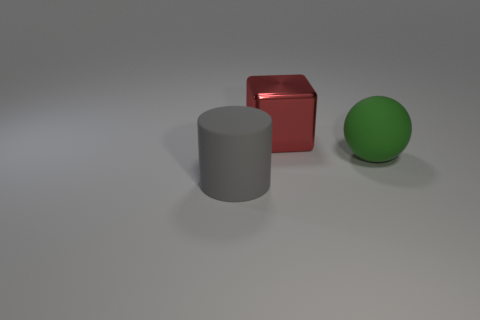What material is the big object behind the big green matte ball?
Ensure brevity in your answer.  Metal. What material is the thing that is behind the rubber thing to the right of the red metallic block?
Your answer should be compact. Metal. Is the number of big things that are on the right side of the metal block greater than the number of tiny gray cylinders?
Provide a succinct answer. Yes. Are there any other things that have the same material as the red object?
Make the answer very short. No. What number of spheres are metal objects or large gray matte things?
Provide a short and direct response. 0. The big rubber object that is left of the big rubber object to the right of the cylinder is what color?
Ensure brevity in your answer.  Gray. The green thing that is made of the same material as the large gray cylinder is what size?
Keep it short and to the point. Large. Are there any big red shiny things behind the big object in front of the rubber object that is right of the gray thing?
Offer a terse response. Yes. How many cubes have the same size as the green sphere?
Give a very brief answer. 1. The big object that is in front of the red thing and right of the gray cylinder has what shape?
Ensure brevity in your answer.  Sphere. 